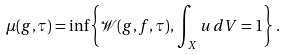<formula> <loc_0><loc_0><loc_500><loc_500>\mu ( g , \tau ) = \inf \left \{ \mathcal { W } ( g , f , \tau ) , \, \int _ { X } u \, d V = 1 \right \} .</formula> 